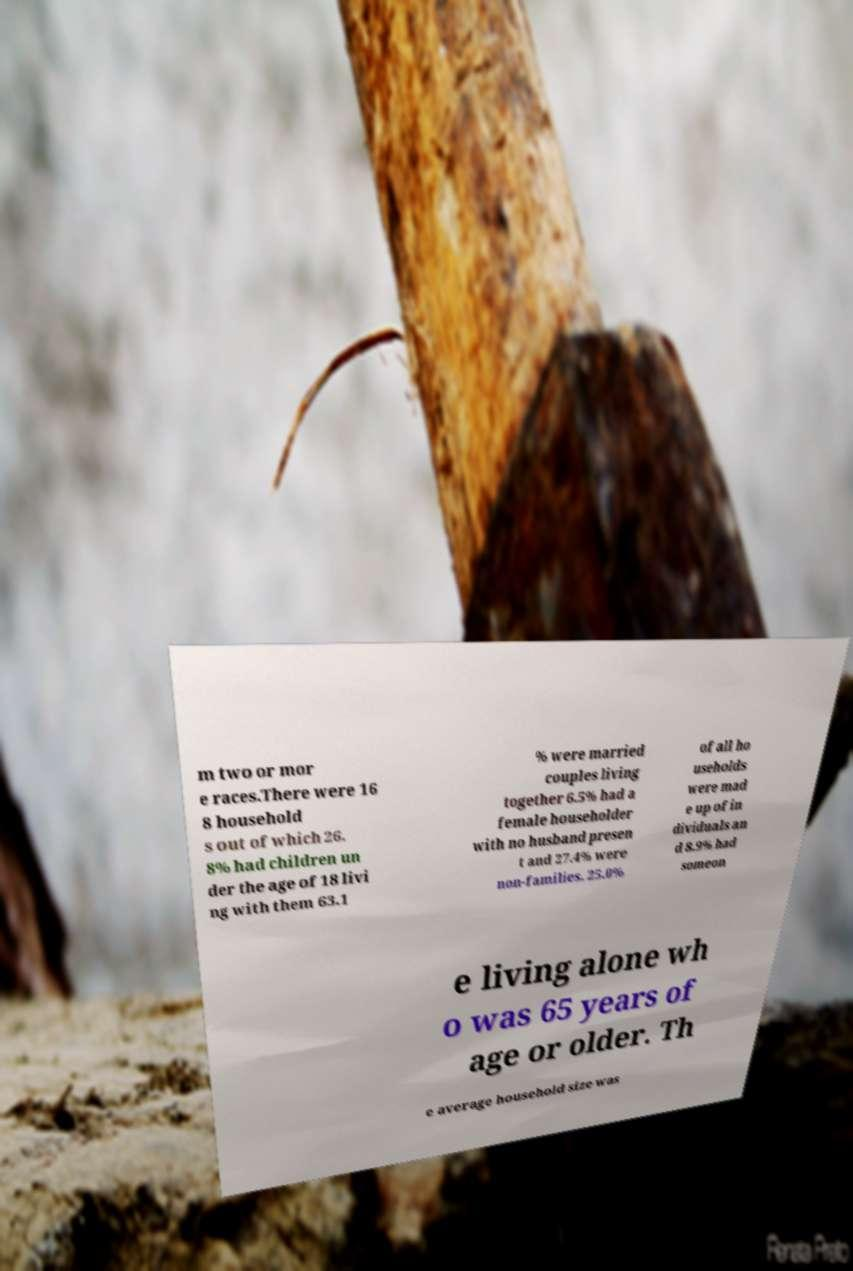For documentation purposes, I need the text within this image transcribed. Could you provide that? m two or mor e races.There were 16 8 household s out of which 26. 8% had children un der the age of 18 livi ng with them 63.1 % were married couples living together 6.5% had a female householder with no husband presen t and 27.4% were non-families. 25.0% of all ho useholds were mad e up of in dividuals an d 8.9% had someon e living alone wh o was 65 years of age or older. Th e average household size was 